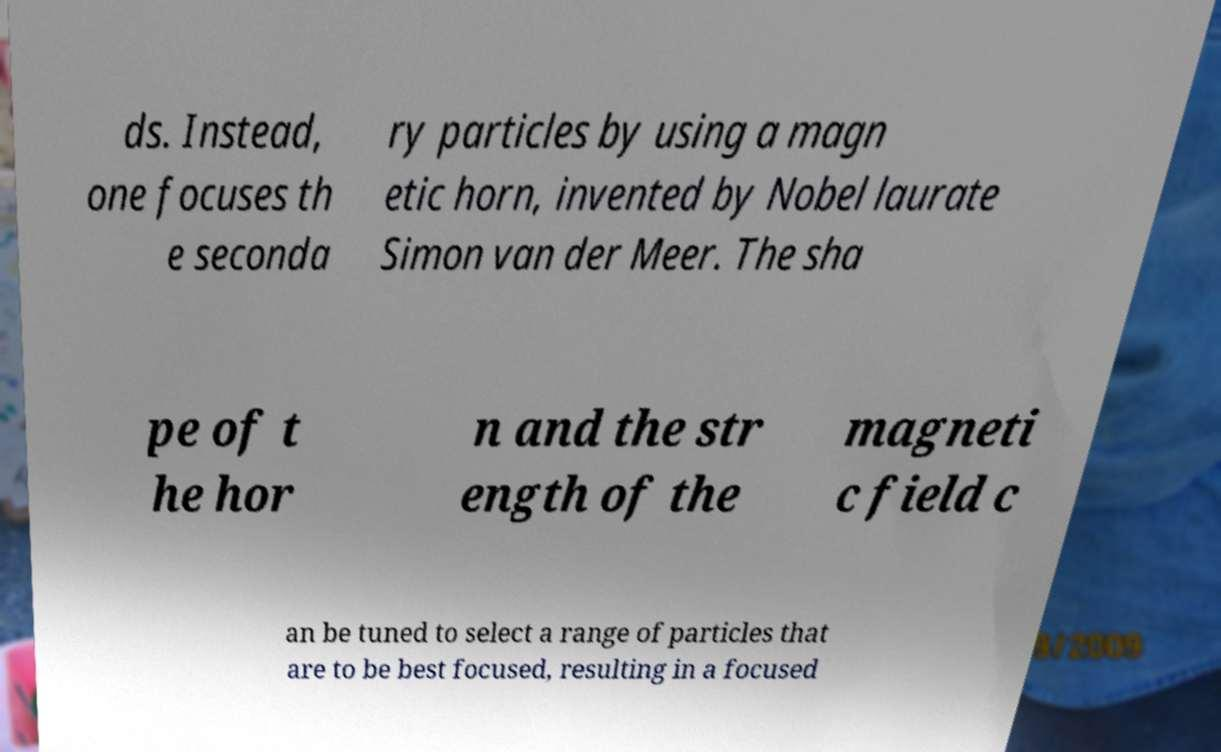I need the written content from this picture converted into text. Can you do that? ds. Instead, one focuses th e seconda ry particles by using a magn etic horn, invented by Nobel laurate Simon van der Meer. The sha pe of t he hor n and the str ength of the magneti c field c an be tuned to select a range of particles that are to be best focused, resulting in a focused 